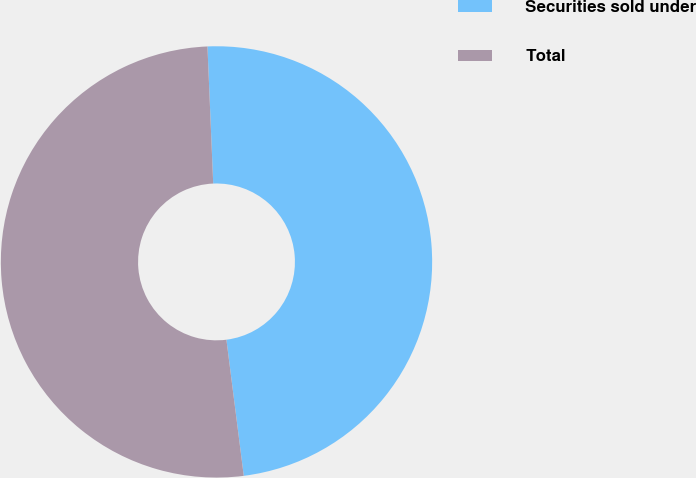Convert chart. <chart><loc_0><loc_0><loc_500><loc_500><pie_chart><fcel>Securities sold under<fcel>Total<nl><fcel>48.65%<fcel>51.35%<nl></chart> 